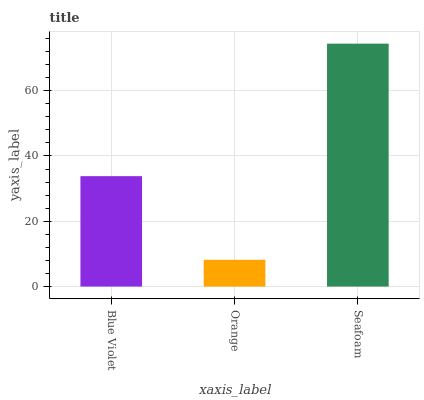Is Orange the minimum?
Answer yes or no. Yes. Is Seafoam the maximum?
Answer yes or no. Yes. Is Seafoam the minimum?
Answer yes or no. No. Is Orange the maximum?
Answer yes or no. No. Is Seafoam greater than Orange?
Answer yes or no. Yes. Is Orange less than Seafoam?
Answer yes or no. Yes. Is Orange greater than Seafoam?
Answer yes or no. No. Is Seafoam less than Orange?
Answer yes or no. No. Is Blue Violet the high median?
Answer yes or no. Yes. Is Blue Violet the low median?
Answer yes or no. Yes. Is Seafoam the high median?
Answer yes or no. No. Is Orange the low median?
Answer yes or no. No. 